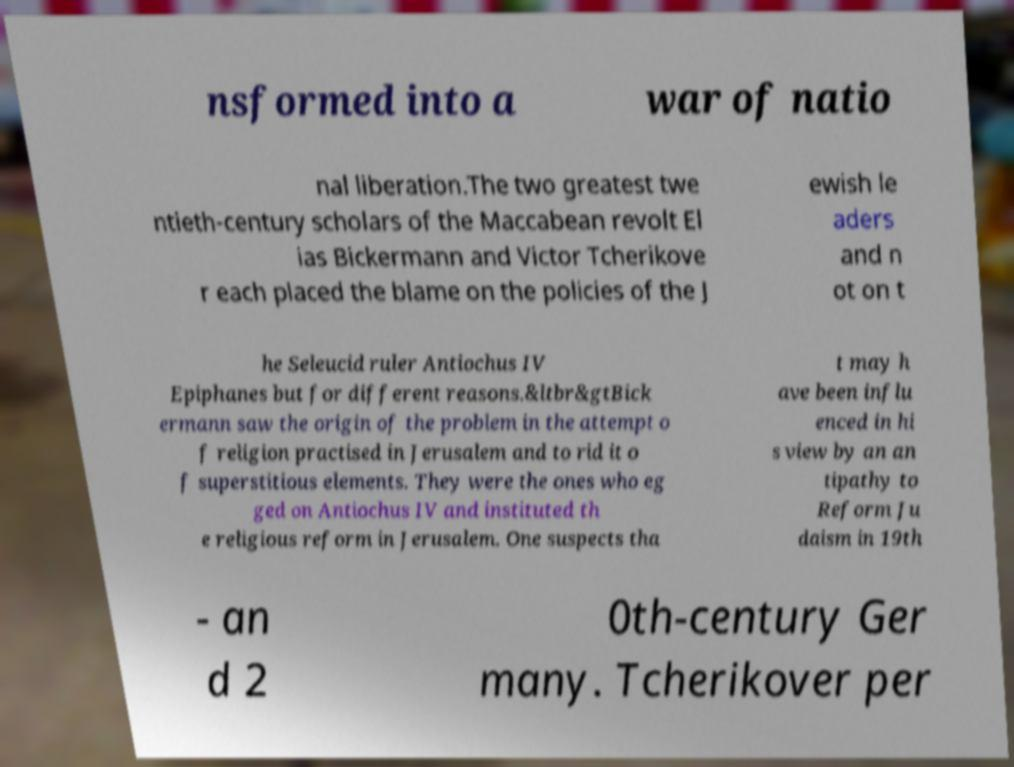What messages or text are displayed in this image? I need them in a readable, typed format. nsformed into a war of natio nal liberation.The two greatest twe ntieth-century scholars of the Maccabean revolt El ias Bickermann and Victor Tcherikove r each placed the blame on the policies of the J ewish le aders and n ot on t he Seleucid ruler Antiochus IV Epiphanes but for different reasons.&ltbr&gtBick ermann saw the origin of the problem in the attempt o f religion practised in Jerusalem and to rid it o f superstitious elements. They were the ones who eg ged on Antiochus IV and instituted th e religious reform in Jerusalem. One suspects tha t may h ave been influ enced in hi s view by an an tipathy to Reform Ju daism in 19th - an d 2 0th-century Ger many. Tcherikover per 